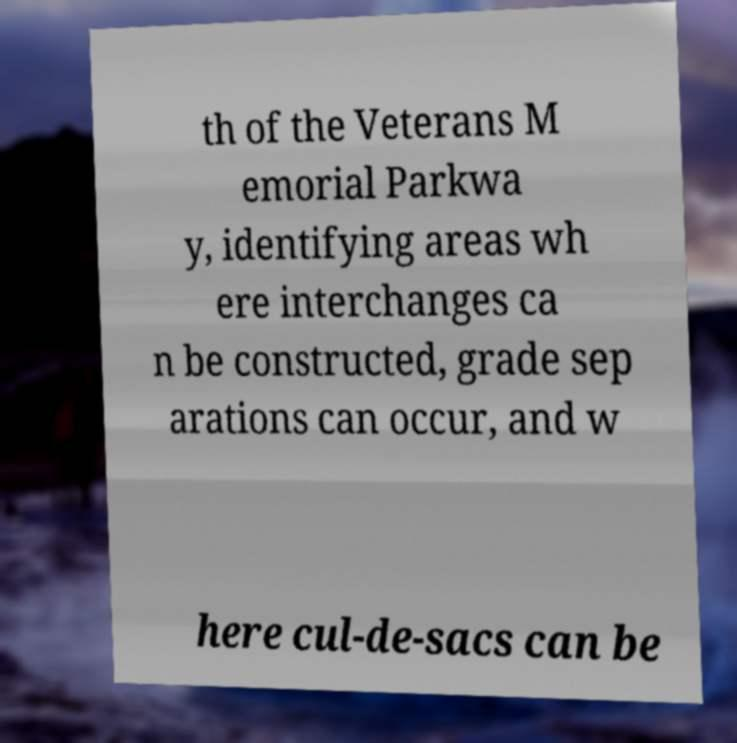Please identify and transcribe the text found in this image. th of the Veterans M emorial Parkwa y, identifying areas wh ere interchanges ca n be constructed, grade sep arations can occur, and w here cul-de-sacs can be 